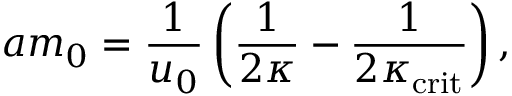Convert formula to latex. <formula><loc_0><loc_0><loc_500><loc_500>a m _ { 0 } = \frac { 1 } { u _ { 0 } } \left ( \frac { 1 } { 2 \kappa } - \frac { 1 } { 2 \kappa _ { c r i t } } \right ) ,</formula> 